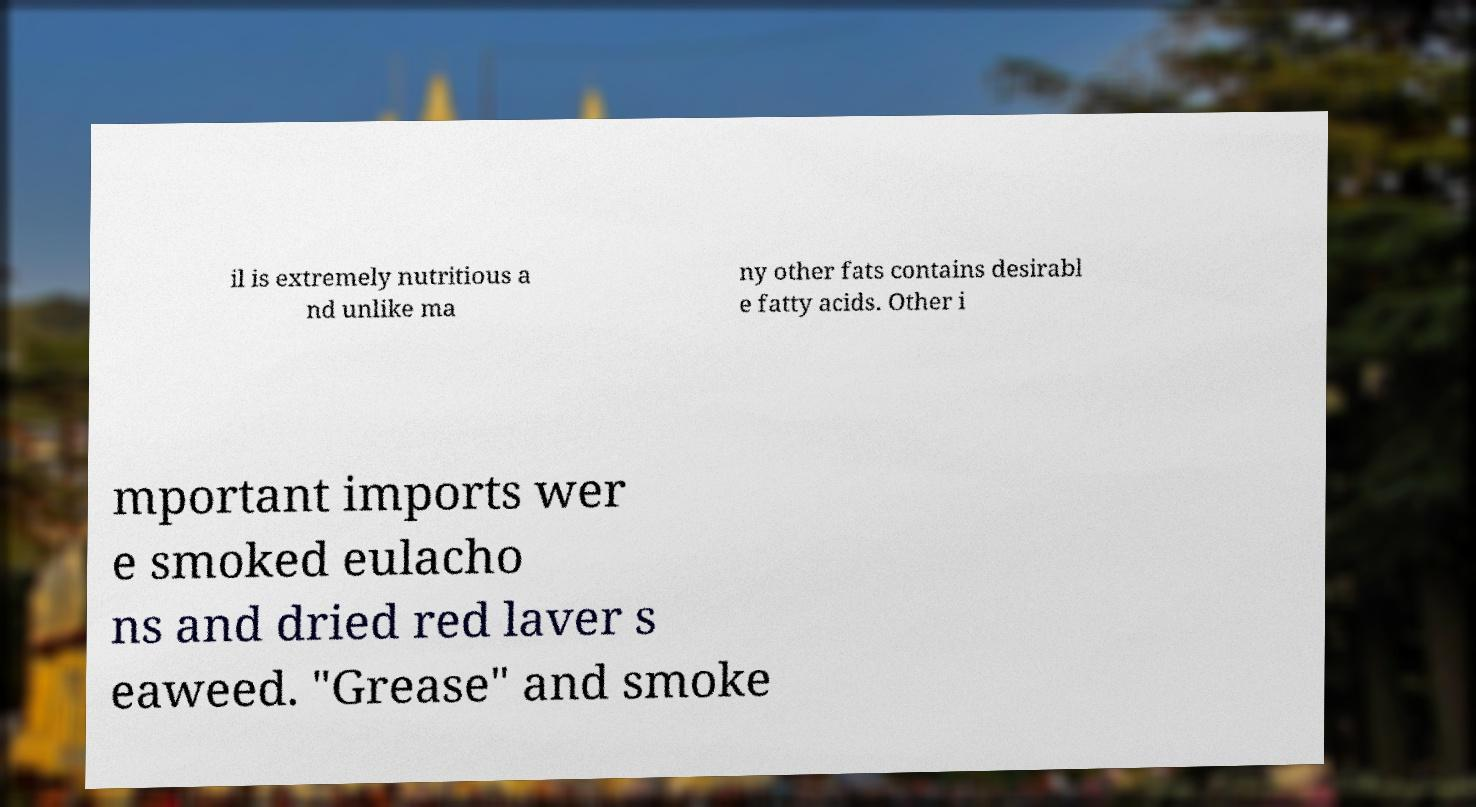Could you extract and type out the text from this image? il is extremely nutritious a nd unlike ma ny other fats contains desirabl e fatty acids. Other i mportant imports wer e smoked eulacho ns and dried red laver s eaweed. "Grease" and smoke 